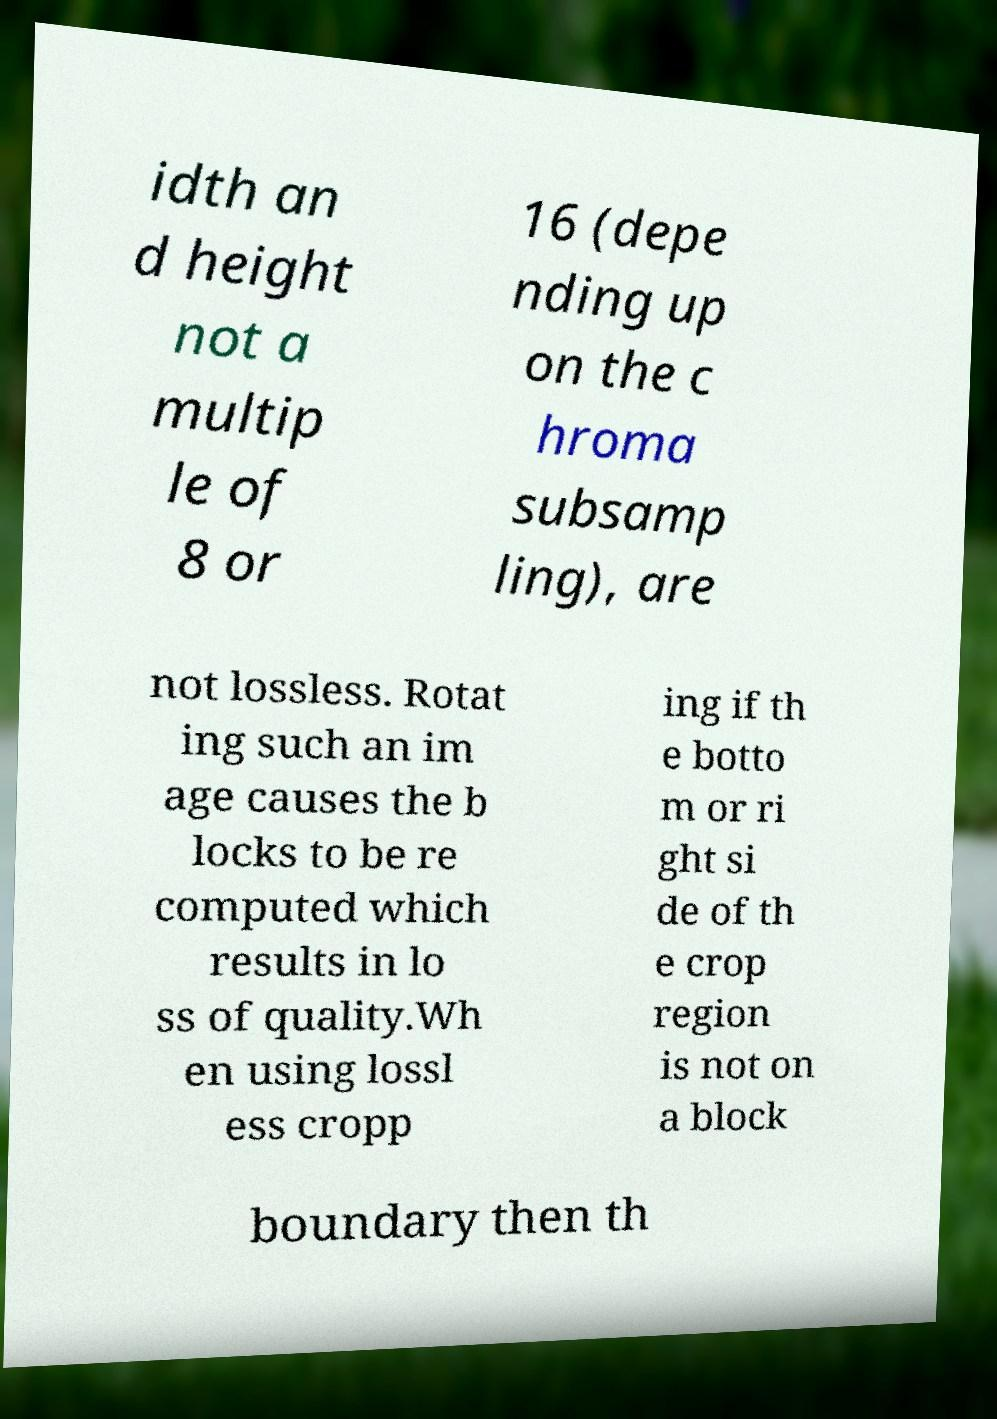There's text embedded in this image that I need extracted. Can you transcribe it verbatim? idth an d height not a multip le of 8 or 16 (depe nding up on the c hroma subsamp ling), are not lossless. Rotat ing such an im age causes the b locks to be re computed which results in lo ss of quality.Wh en using lossl ess cropp ing if th e botto m or ri ght si de of th e crop region is not on a block boundary then th 